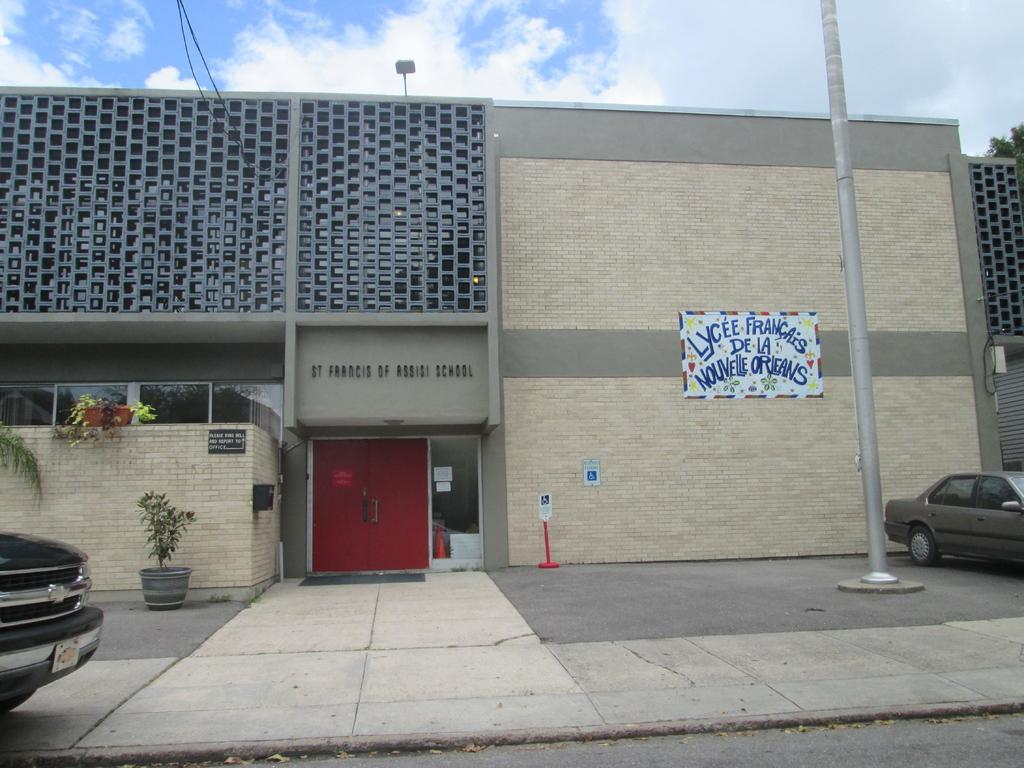What types of objects can be seen in the image? There are vehicles, plants, and boards in the image. What type of structure is present in the image? There is a building in the image. What can be seen in the background of the image? The sky is visible in the background of the image. What type of sand can be seen in the image? There is no sand present in the image. How many roses are visible in the image? There are no roses present in the image. 